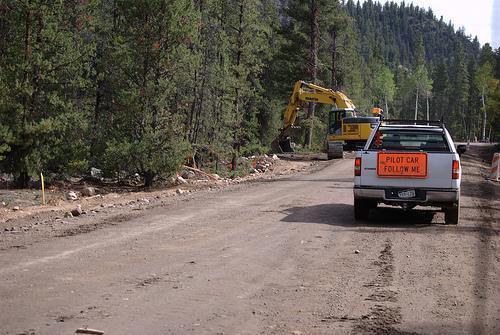How many vehicles are there?
Give a very brief answer. 2. 